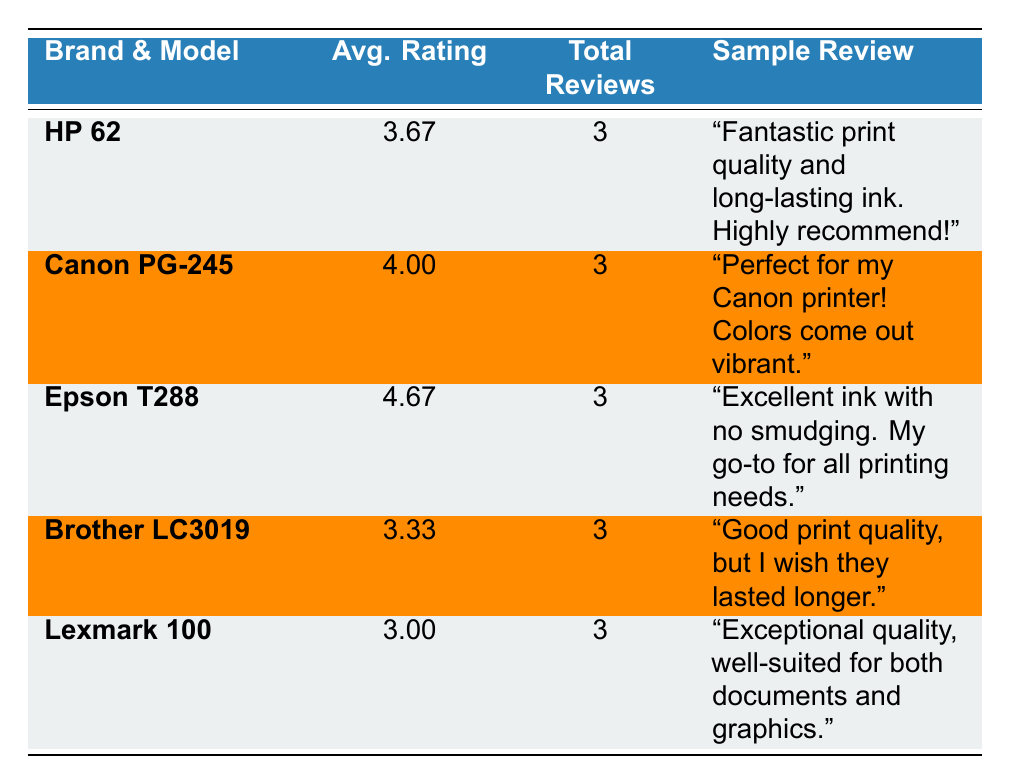What is the average rating for the Canon PG-245 ink cartridge? The average rating for Canon PG-245 is directly listed in the table under the "Avg. Rating" column, which shows 4.00.
Answer: 4.00 Which brand has the highest average rating? The average ratings for each brand are displayed, and the highest is for Epson T288 with an average rating of 4.67.
Answer: Epson T288 How many reviews does the Lexmark 100 ink cartridge have? The total number of reviews for Lexmark 100 is provided in the "Total Reviews" column, which indicates it has 3 reviews.
Answer: 3 Is the HP 62 rated higher than the Brother LC3019? HP 62 has an average rating of 3.67, while Brother LC3019 has an average rating of 3.33. Therefore, HP 62 is rated higher.
Answer: Yes What is the difference between the average ratings of Epson T288 and Lexmark 100? The average rating for Epson T288 is 4.67 and for Lexmark 100 it is 3.00. To find the difference, subtract Lexmark's rating from Epson's, which is 4.67 - 3.00 = 1.67.
Answer: 1.67 How many customer reviews mention issues with compatibility for HP 62? There is only one customer review for HP 62 mentioning compatibility issues, which is rated 2. This information can be found by reading the customer reviews provided for HP 62.
Answer: 1 Which brand has a sample review mentioning the ink runs out too quickly? The sample reviews indicate that both Canon PG-245 and HP 62 mention issues with running out of ink quickly. Canon mentions it in a 3-star review and HP in a 2-star review.
Answer: Canon PG-245 and HP 62 What percentage of the reviews for Brother LC3019 are rated 4 or higher? The Brother LC3019 has a total of 3 reviews, with 2 of them rated 4. To find the percentage, compute (2 / 3) * 100 = 66.67%.
Answer: 66.67% What is the lowest rating received by the Lexmark 100? The reviews for Lexmark 100 show ratings of 5, 3, and 1. The lowest of these ratings is 1, which is documented in the reviews section.
Answer: 1 